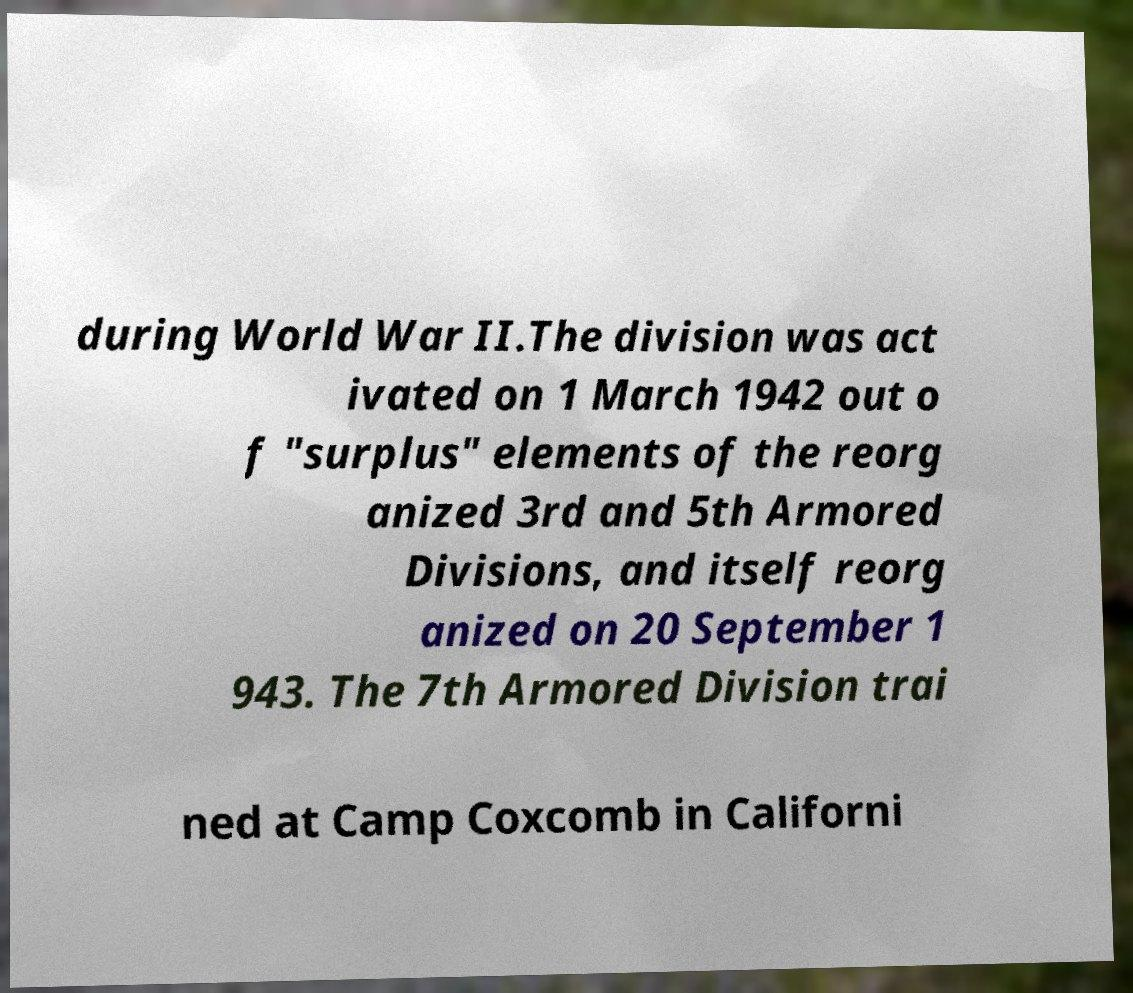What messages or text are displayed in this image? I need them in a readable, typed format. during World War II.The division was act ivated on 1 March 1942 out o f "surplus" elements of the reorg anized 3rd and 5th Armored Divisions, and itself reorg anized on 20 September 1 943. The 7th Armored Division trai ned at Camp Coxcomb in Californi 